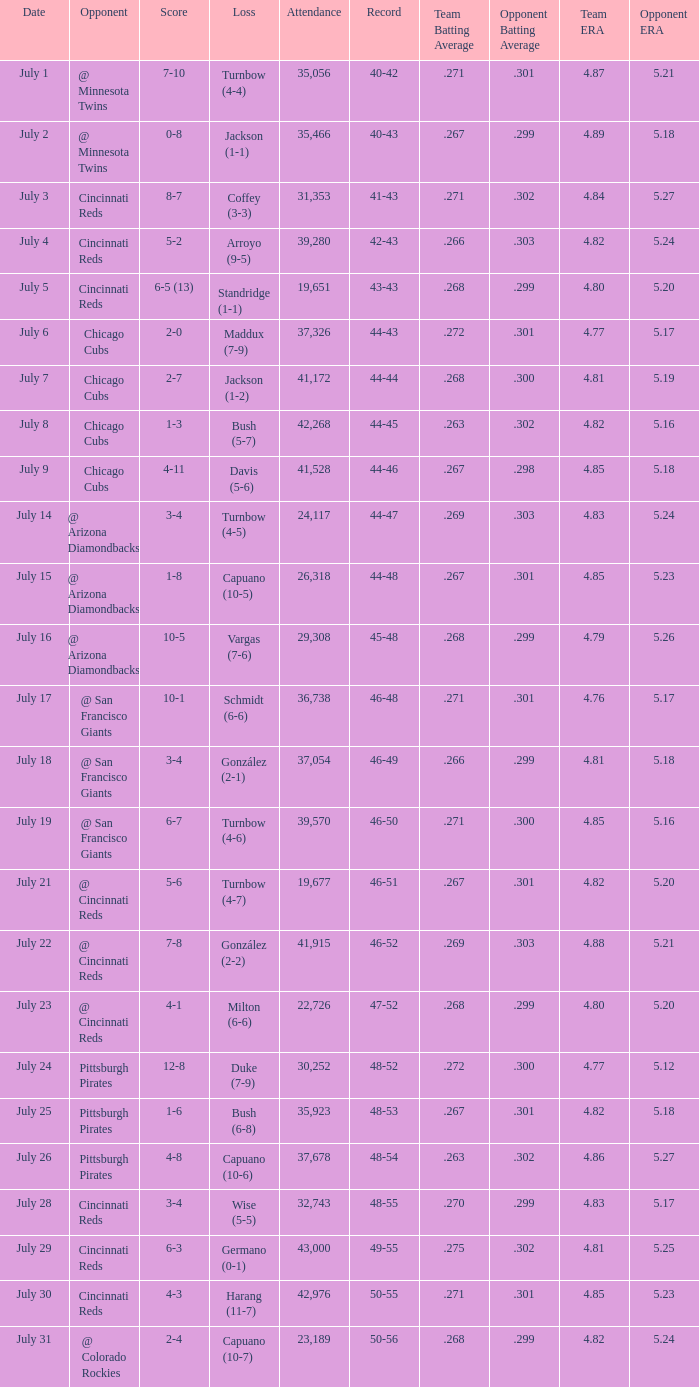What was the record at the game that had a score of 7-10? 40-42. 